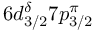<formula> <loc_0><loc_0><loc_500><loc_500>6 d _ { 3 / 2 } ^ { \delta } 7 p _ { 3 / 2 } ^ { \pi }</formula> 